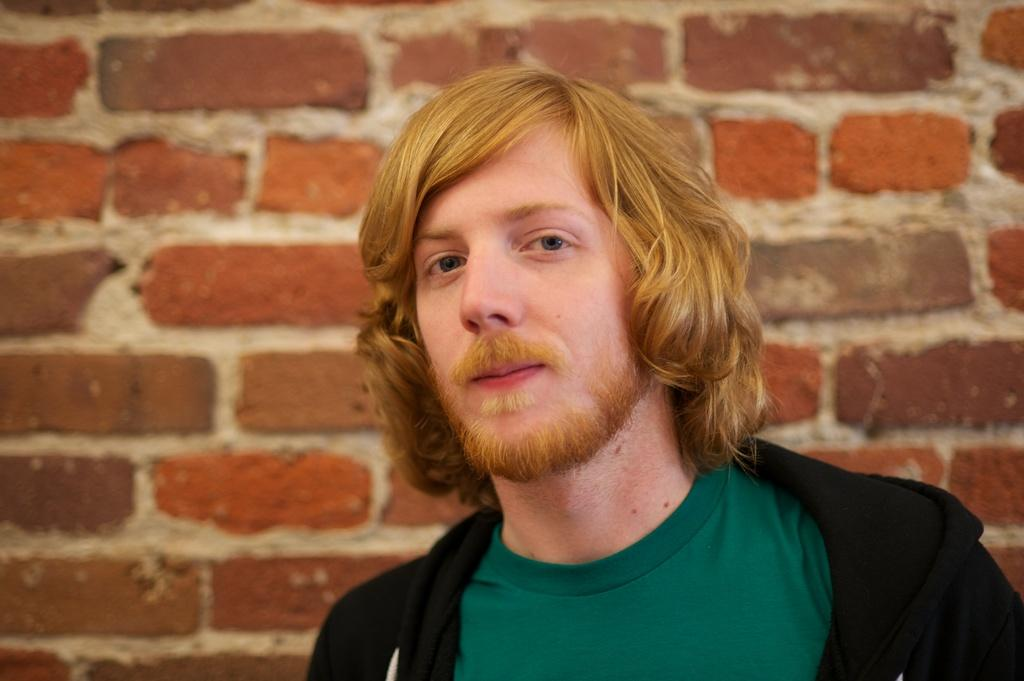Who is present in the image? There is a man in the image. On which side of the image is the man located? The man is on the right side of the image. What is the man wearing in the image? The man is wearing a black color jacket. What can be seen in the background of the image? There is a brick wall in the background of the image. Can you see any deer in the image? No, there are no deer present in the image. What type of tub is the man using in the image? There is no tub present in the image; the man is standing next to a brick wall. 